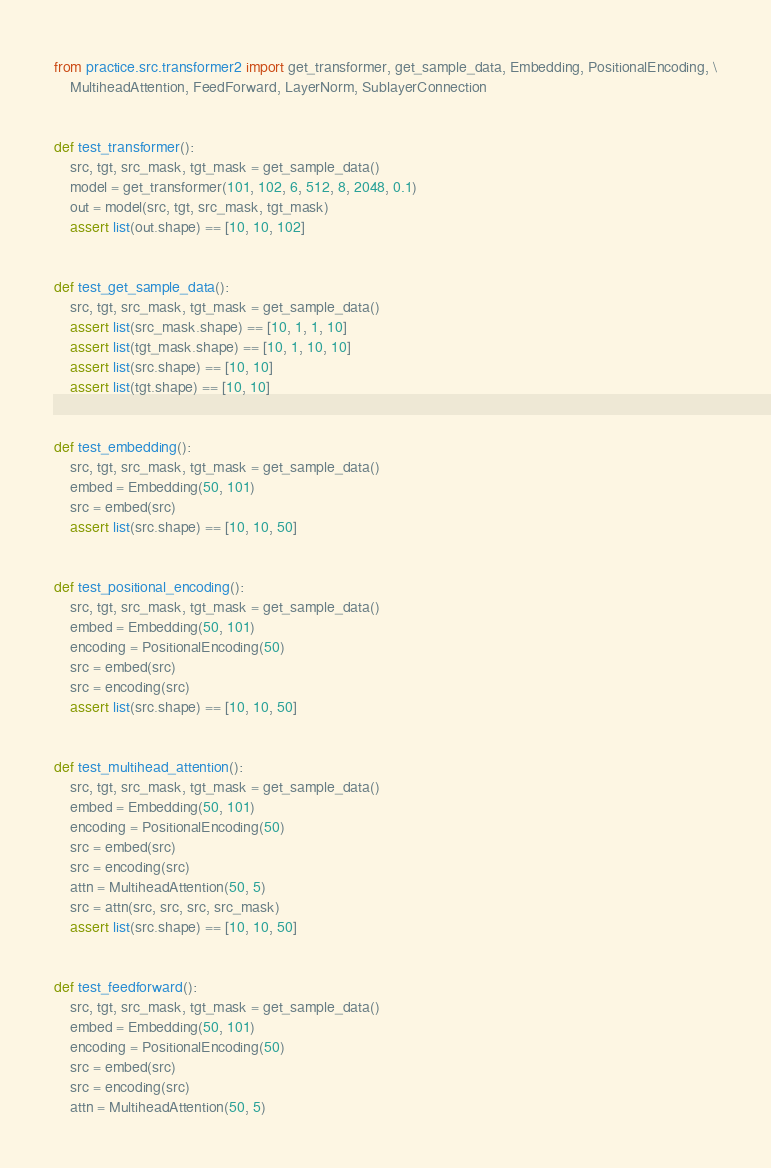<code> <loc_0><loc_0><loc_500><loc_500><_Python_>from practice.src.transformer2 import get_transformer, get_sample_data, Embedding, PositionalEncoding, \
    MultiheadAttention, FeedForward, LayerNorm, SublayerConnection


def test_transformer():
    src, tgt, src_mask, tgt_mask = get_sample_data()
    model = get_transformer(101, 102, 6, 512, 8, 2048, 0.1)
    out = model(src, tgt, src_mask, tgt_mask)
    assert list(out.shape) == [10, 10, 102]


def test_get_sample_data():
    src, tgt, src_mask, tgt_mask = get_sample_data()
    assert list(src_mask.shape) == [10, 1, 1, 10]
    assert list(tgt_mask.shape) == [10, 1, 10, 10]
    assert list(src.shape) == [10, 10]
    assert list(tgt.shape) == [10, 10]


def test_embedding():
    src, tgt, src_mask, tgt_mask = get_sample_data()
    embed = Embedding(50, 101)
    src = embed(src)
    assert list(src.shape) == [10, 10, 50]


def test_positional_encoding():
    src, tgt, src_mask, tgt_mask = get_sample_data()
    embed = Embedding(50, 101)
    encoding = PositionalEncoding(50)
    src = embed(src)
    src = encoding(src)
    assert list(src.shape) == [10, 10, 50]


def test_multihead_attention():
    src, tgt, src_mask, tgt_mask = get_sample_data()
    embed = Embedding(50, 101)
    encoding = PositionalEncoding(50)
    src = embed(src)
    src = encoding(src)
    attn = MultiheadAttention(50, 5)
    src = attn(src, src, src, src_mask)
    assert list(src.shape) == [10, 10, 50]


def test_feedforward():
    src, tgt, src_mask, tgt_mask = get_sample_data()
    embed = Embedding(50, 101)
    encoding = PositionalEncoding(50)
    src = embed(src)
    src = encoding(src)
    attn = MultiheadAttention(50, 5)</code> 